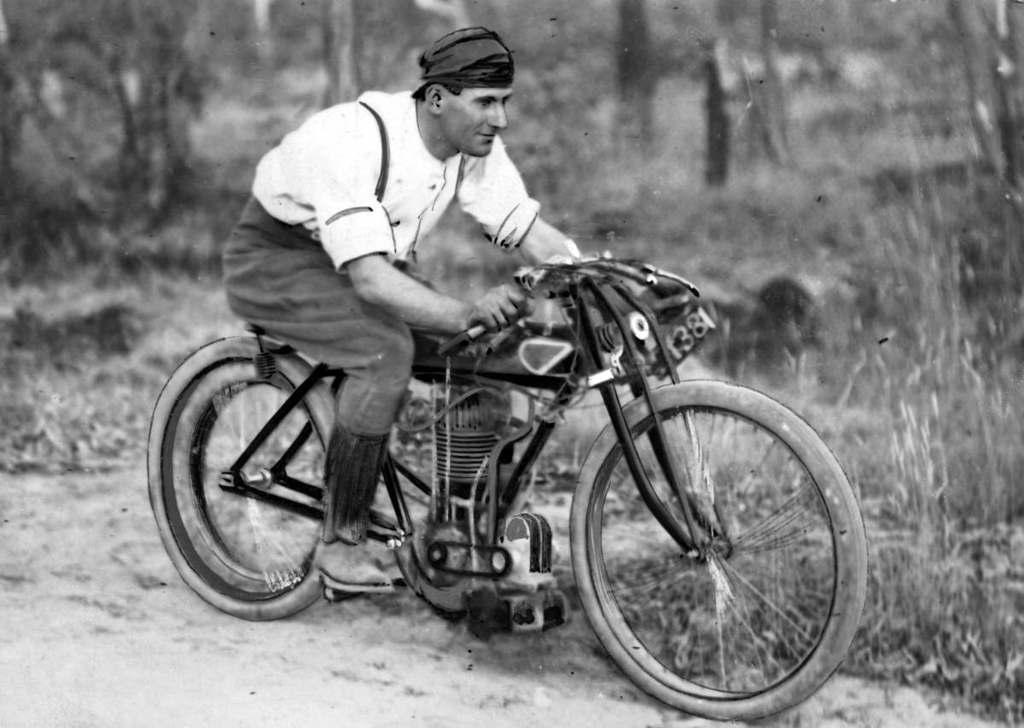Who is present in the image? There is a man in the image. What is the man doing in the image? The man is sitting on a bicycle. What type of vegetation can be seen in the image? There are trees and plants on the ground in the image. What type of ticket does the man have for the band's performance in the image? There is no mention of a band or a ticket in the image; it only features a man sitting on a bicycle with trees and plants in the background. 